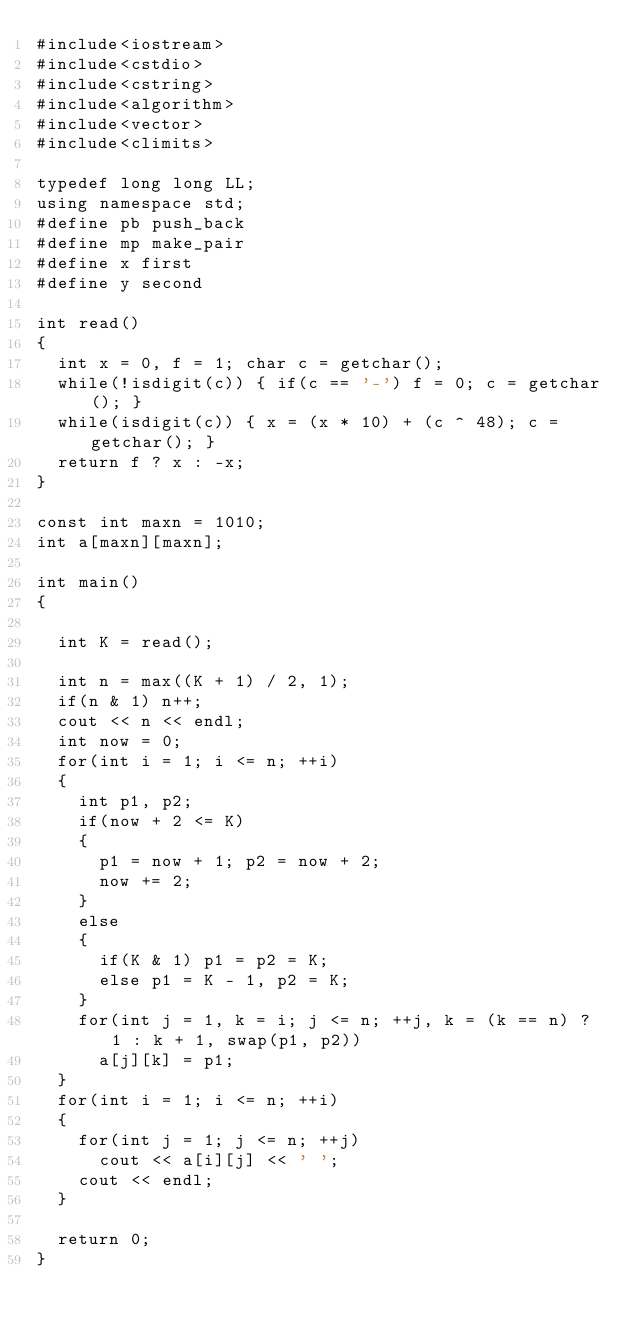Convert code to text. <code><loc_0><loc_0><loc_500><loc_500><_C++_>#include<iostream>
#include<cstdio>
#include<cstring>
#include<algorithm>
#include<vector>
#include<climits>

typedef long long LL;
using namespace std;
#define pb push_back
#define mp make_pair
#define x first
#define y second

int read()
{
	int x = 0, f = 1; char c = getchar();
	while(!isdigit(c)) { if(c == '-') f = 0; c = getchar(); }
	while(isdigit(c)) { x = (x * 10) + (c ^ 48); c = getchar(); }
	return f ? x : -x;
}

const int maxn = 1010;
int a[maxn][maxn];

int main()
{

	int K = read();

	int n = max((K + 1) / 2, 1);
	if(n & 1) n++;
	cout << n << endl;
	int now = 0;
	for(int i = 1; i <= n; ++i)
	{
		int p1, p2;
		if(now + 2 <= K)
		{
			p1 = now + 1; p2 = now + 2;
			now += 2;
		}
		else 
		{
			if(K & 1) p1 = p2 = K;
			else p1 = K - 1, p2 = K;
		}
		for(int j = 1, k = i; j <= n; ++j, k = (k == n) ? 1 : k + 1, swap(p1, p2))
			a[j][k] = p1;
	}
	for(int i = 1; i <= n; ++i)
	{
		for(int j = 1; j <= n; ++j)
			cout << a[i][j] << ' ';
		cout << endl;
	}

	return 0;
}</code> 